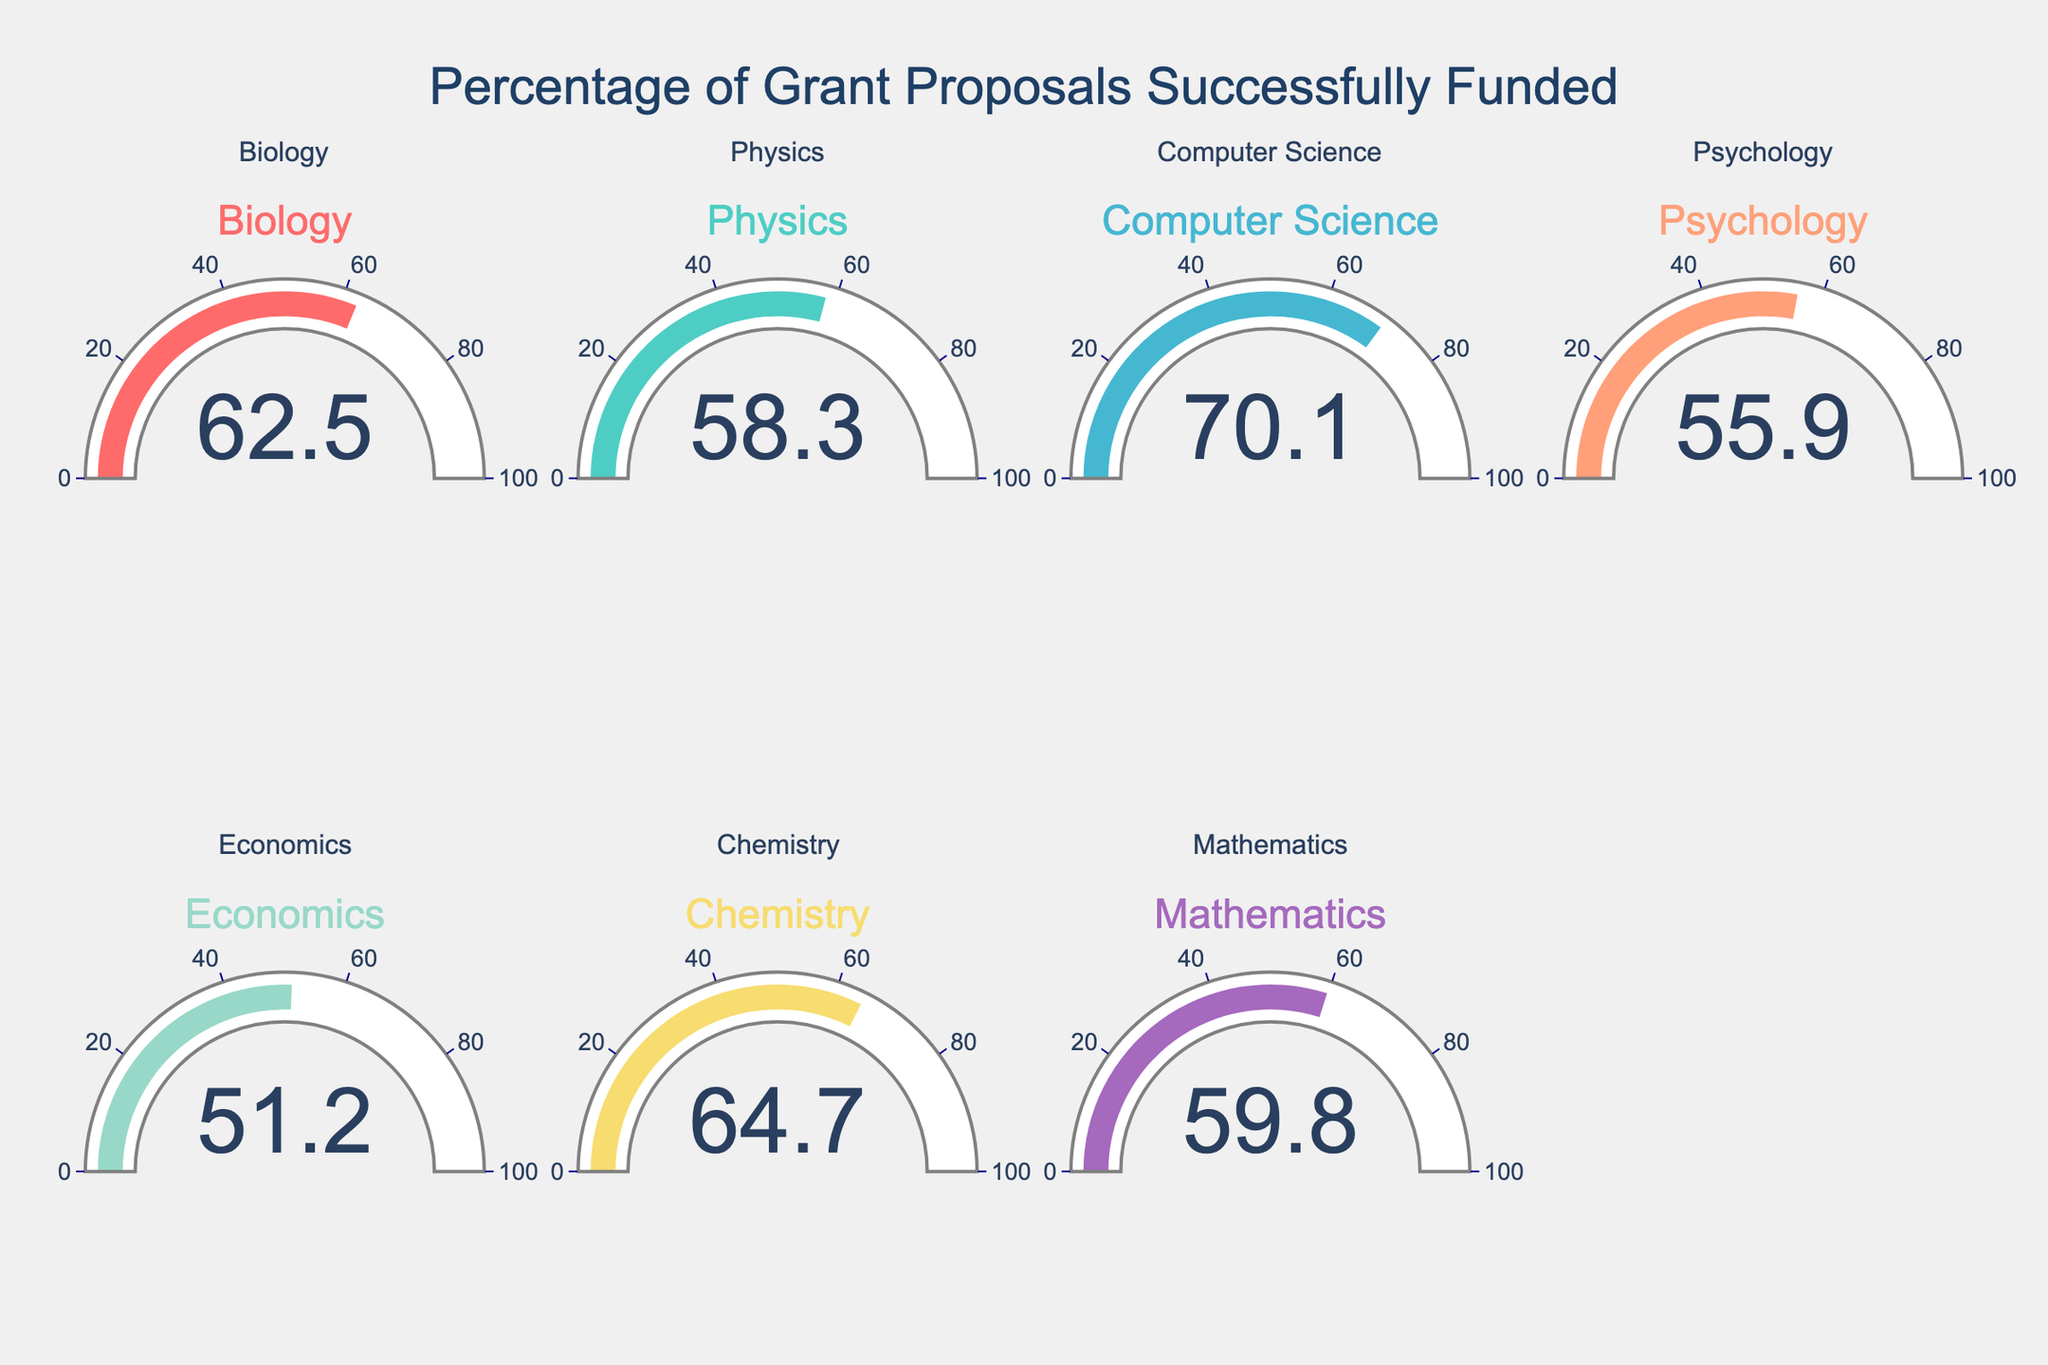What is the funding rate for the Computer Science department? The gauge chart for the Computer Science department shows the value of 70.1%. The number on the gauge represents the funding rate for each department.
Answer: 70.1% Which department has the highest funding rate? To find the department with the highest funding rate, examine the values displayed on each gauge. The Biology department shows a funding rate of 62.5%, Physics 58.3%, Computer Science 70.1%, Psychology 55.9%, Economics 51.2%, Chemistry 64.7%, and Mathematics 59.8%. The highest value is in the Computer Science department.
Answer: Computer Science What is the average funding rate across all departments? Add each department's funding rates (62.5 + 58.3 + 70.1 + 55.9 + 51.2 + 64.7 + 59.8) and then divide by the number of departments (7). Calculated as: (62.5 + 58.3 + 70.1 + 55.9 + 51.2 + 64.7 + 59.8) / 7 = 422.5 / 7 = 60.36%.
Answer: 60.36% How much higher is the funding rate for Biology compared to Psychology? The funding rate for Biology is 62.5%, and for Psychology, it is 55.9%. To find the difference, subtract Psychology's rate from Biology's rate: 62.5 - 55.9 = 6.6%.
Answer: 6.6% Which departments have a funding rate above 60%? Look at each gauge and note the departments that have values greater than 60%. The Biology department (62.5%), the Computer Science department (70.1%), and the Chemistry department (64.7%) all have rates above 60%.
Answer: Biology, Computer Science, Chemistry What is the median funding rate among all departments? To find the median, first order the funding rates: 51.2, 55.9, 58.3, 59.8, 62.5, 64.7, 70.1. The median is the middle value in this ordered list: 59.8%.
Answer: 59.8% What is the difference in funding rates between Chemistry and Mathematics? The funding rate for Chemistry is 64.7%, and for Mathematics, it is 59.8%. Subtracting the Mathematics rate from the Chemistry rate: 64.7 - 59.8 = 4.9%.
Answer: 4.9% Which department has the lowest funding rate? By examining the funding rates displayed on the gauges, the department with the lowest rate is Economics with a funding rate of 51.2%.
Answer: Economics 